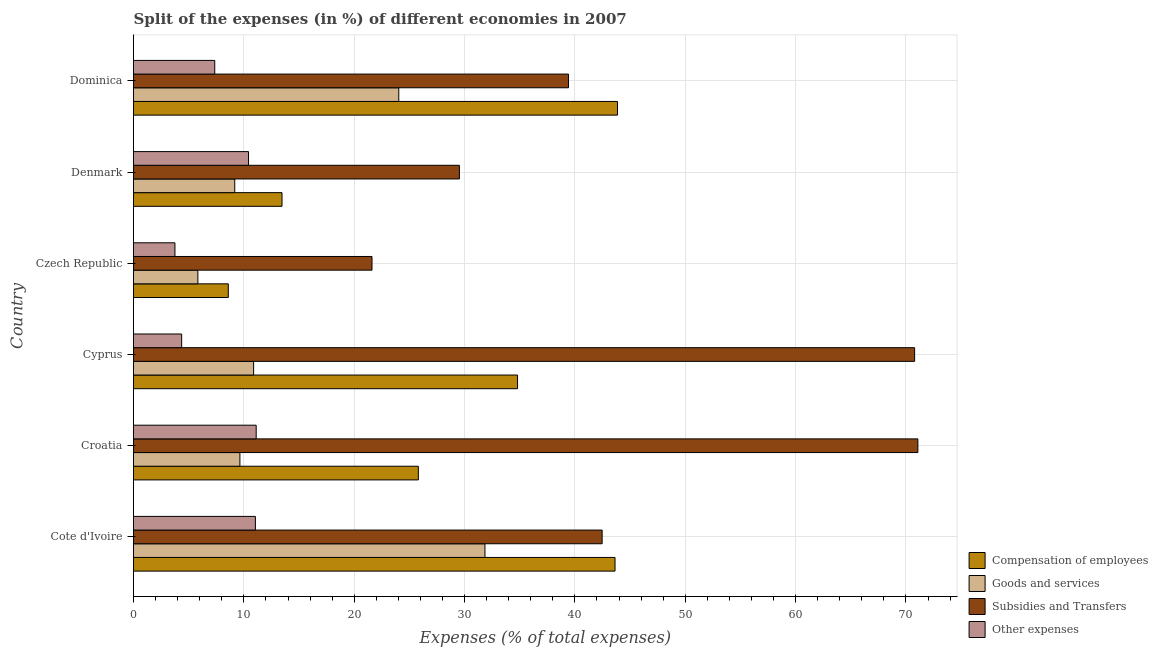How many groups of bars are there?
Give a very brief answer. 6. Are the number of bars per tick equal to the number of legend labels?
Your answer should be very brief. Yes. What is the label of the 2nd group of bars from the top?
Your answer should be compact. Denmark. In how many cases, is the number of bars for a given country not equal to the number of legend labels?
Keep it short and to the point. 0. What is the percentage of amount spent on goods and services in Cote d'Ivoire?
Your response must be concise. 31.85. Across all countries, what is the maximum percentage of amount spent on compensation of employees?
Your answer should be compact. 43.86. Across all countries, what is the minimum percentage of amount spent on subsidies?
Your answer should be compact. 21.61. In which country was the percentage of amount spent on other expenses maximum?
Make the answer very short. Croatia. In which country was the percentage of amount spent on compensation of employees minimum?
Provide a succinct answer. Czech Republic. What is the total percentage of amount spent on subsidies in the graph?
Make the answer very short. 274.9. What is the difference between the percentage of amount spent on compensation of employees in Czech Republic and that in Dominica?
Offer a terse response. -35.27. What is the difference between the percentage of amount spent on other expenses in Croatia and the percentage of amount spent on compensation of employees in Cote d'Ivoire?
Ensure brevity in your answer.  -32.52. What is the average percentage of amount spent on subsidies per country?
Your answer should be very brief. 45.82. What is the difference between the percentage of amount spent on goods and services and percentage of amount spent on other expenses in Cote d'Ivoire?
Provide a succinct answer. 20.8. In how many countries, is the percentage of amount spent on subsidies greater than 54 %?
Keep it short and to the point. 2. What is the ratio of the percentage of amount spent on subsidies in Croatia to that in Dominica?
Offer a terse response. 1.8. What is the difference between the highest and the second highest percentage of amount spent on goods and services?
Offer a very short reply. 7.81. What is the difference between the highest and the lowest percentage of amount spent on subsidies?
Ensure brevity in your answer.  49.47. Is the sum of the percentage of amount spent on compensation of employees in Cote d'Ivoire and Czech Republic greater than the maximum percentage of amount spent on goods and services across all countries?
Offer a very short reply. Yes. What does the 4th bar from the top in Dominica represents?
Offer a terse response. Compensation of employees. What does the 4th bar from the bottom in Czech Republic represents?
Your answer should be very brief. Other expenses. How many countries are there in the graph?
Give a very brief answer. 6. Are the values on the major ticks of X-axis written in scientific E-notation?
Make the answer very short. No. Does the graph contain grids?
Keep it short and to the point. Yes. How many legend labels are there?
Keep it short and to the point. 4. What is the title of the graph?
Give a very brief answer. Split of the expenses (in %) of different economies in 2007. Does "Bird species" appear as one of the legend labels in the graph?
Offer a terse response. No. What is the label or title of the X-axis?
Keep it short and to the point. Expenses (% of total expenses). What is the label or title of the Y-axis?
Offer a terse response. Country. What is the Expenses (% of total expenses) in Compensation of employees in Cote d'Ivoire?
Offer a terse response. 43.64. What is the Expenses (% of total expenses) in Goods and services in Cote d'Ivoire?
Offer a very short reply. 31.85. What is the Expenses (% of total expenses) of Subsidies and Transfers in Cote d'Ivoire?
Your response must be concise. 42.47. What is the Expenses (% of total expenses) in Other expenses in Cote d'Ivoire?
Make the answer very short. 11.04. What is the Expenses (% of total expenses) of Compensation of employees in Croatia?
Offer a very short reply. 25.81. What is the Expenses (% of total expenses) of Goods and services in Croatia?
Keep it short and to the point. 9.64. What is the Expenses (% of total expenses) in Subsidies and Transfers in Croatia?
Make the answer very short. 71.08. What is the Expenses (% of total expenses) in Other expenses in Croatia?
Provide a short and direct response. 11.12. What is the Expenses (% of total expenses) of Compensation of employees in Cyprus?
Give a very brief answer. 34.8. What is the Expenses (% of total expenses) in Goods and services in Cyprus?
Offer a very short reply. 10.89. What is the Expenses (% of total expenses) in Subsidies and Transfers in Cyprus?
Give a very brief answer. 70.79. What is the Expenses (% of total expenses) in Other expenses in Cyprus?
Ensure brevity in your answer.  4.36. What is the Expenses (% of total expenses) of Compensation of employees in Czech Republic?
Offer a terse response. 8.59. What is the Expenses (% of total expenses) in Goods and services in Czech Republic?
Give a very brief answer. 5.83. What is the Expenses (% of total expenses) in Subsidies and Transfers in Czech Republic?
Your response must be concise. 21.61. What is the Expenses (% of total expenses) of Other expenses in Czech Republic?
Provide a short and direct response. 3.75. What is the Expenses (% of total expenses) of Compensation of employees in Denmark?
Your answer should be compact. 13.46. What is the Expenses (% of total expenses) of Goods and services in Denmark?
Ensure brevity in your answer.  9.17. What is the Expenses (% of total expenses) of Subsidies and Transfers in Denmark?
Give a very brief answer. 29.53. What is the Expenses (% of total expenses) in Other expenses in Denmark?
Offer a terse response. 10.42. What is the Expenses (% of total expenses) in Compensation of employees in Dominica?
Provide a short and direct response. 43.86. What is the Expenses (% of total expenses) of Goods and services in Dominica?
Your answer should be very brief. 24.04. What is the Expenses (% of total expenses) of Subsidies and Transfers in Dominica?
Offer a terse response. 39.42. What is the Expenses (% of total expenses) of Other expenses in Dominica?
Make the answer very short. 7.36. Across all countries, what is the maximum Expenses (% of total expenses) in Compensation of employees?
Ensure brevity in your answer.  43.86. Across all countries, what is the maximum Expenses (% of total expenses) in Goods and services?
Offer a very short reply. 31.85. Across all countries, what is the maximum Expenses (% of total expenses) in Subsidies and Transfers?
Provide a succinct answer. 71.08. Across all countries, what is the maximum Expenses (% of total expenses) of Other expenses?
Make the answer very short. 11.12. Across all countries, what is the minimum Expenses (% of total expenses) in Compensation of employees?
Ensure brevity in your answer.  8.59. Across all countries, what is the minimum Expenses (% of total expenses) of Goods and services?
Your answer should be very brief. 5.83. Across all countries, what is the minimum Expenses (% of total expenses) in Subsidies and Transfers?
Keep it short and to the point. 21.61. Across all countries, what is the minimum Expenses (% of total expenses) of Other expenses?
Your answer should be very brief. 3.75. What is the total Expenses (% of total expenses) in Compensation of employees in the graph?
Offer a terse response. 170.16. What is the total Expenses (% of total expenses) in Goods and services in the graph?
Provide a succinct answer. 91.42. What is the total Expenses (% of total expenses) of Subsidies and Transfers in the graph?
Give a very brief answer. 274.9. What is the total Expenses (% of total expenses) of Other expenses in the graph?
Keep it short and to the point. 48.06. What is the difference between the Expenses (% of total expenses) of Compensation of employees in Cote d'Ivoire and that in Croatia?
Give a very brief answer. 17.82. What is the difference between the Expenses (% of total expenses) of Goods and services in Cote d'Ivoire and that in Croatia?
Provide a short and direct response. 22.21. What is the difference between the Expenses (% of total expenses) in Subsidies and Transfers in Cote d'Ivoire and that in Croatia?
Provide a short and direct response. -28.61. What is the difference between the Expenses (% of total expenses) in Other expenses in Cote d'Ivoire and that in Croatia?
Your answer should be compact. -0.07. What is the difference between the Expenses (% of total expenses) in Compensation of employees in Cote d'Ivoire and that in Cyprus?
Make the answer very short. 8.83. What is the difference between the Expenses (% of total expenses) in Goods and services in Cote d'Ivoire and that in Cyprus?
Provide a short and direct response. 20.96. What is the difference between the Expenses (% of total expenses) of Subsidies and Transfers in Cote d'Ivoire and that in Cyprus?
Give a very brief answer. -28.32. What is the difference between the Expenses (% of total expenses) of Other expenses in Cote d'Ivoire and that in Cyprus?
Offer a terse response. 6.68. What is the difference between the Expenses (% of total expenses) in Compensation of employees in Cote d'Ivoire and that in Czech Republic?
Offer a terse response. 35.05. What is the difference between the Expenses (% of total expenses) in Goods and services in Cote d'Ivoire and that in Czech Republic?
Keep it short and to the point. 26.02. What is the difference between the Expenses (% of total expenses) in Subsidies and Transfers in Cote d'Ivoire and that in Czech Republic?
Keep it short and to the point. 20.86. What is the difference between the Expenses (% of total expenses) of Other expenses in Cote d'Ivoire and that in Czech Republic?
Ensure brevity in your answer.  7.29. What is the difference between the Expenses (% of total expenses) of Compensation of employees in Cote d'Ivoire and that in Denmark?
Your response must be concise. 30.18. What is the difference between the Expenses (% of total expenses) in Goods and services in Cote d'Ivoire and that in Denmark?
Make the answer very short. 22.67. What is the difference between the Expenses (% of total expenses) in Subsidies and Transfers in Cote d'Ivoire and that in Denmark?
Provide a short and direct response. 12.93. What is the difference between the Expenses (% of total expenses) of Other expenses in Cote d'Ivoire and that in Denmark?
Your answer should be very brief. 0.62. What is the difference between the Expenses (% of total expenses) of Compensation of employees in Cote d'Ivoire and that in Dominica?
Offer a terse response. -0.22. What is the difference between the Expenses (% of total expenses) in Goods and services in Cote d'Ivoire and that in Dominica?
Provide a succinct answer. 7.81. What is the difference between the Expenses (% of total expenses) of Subsidies and Transfers in Cote d'Ivoire and that in Dominica?
Your response must be concise. 3.05. What is the difference between the Expenses (% of total expenses) of Other expenses in Cote d'Ivoire and that in Dominica?
Keep it short and to the point. 3.68. What is the difference between the Expenses (% of total expenses) of Compensation of employees in Croatia and that in Cyprus?
Give a very brief answer. -8.99. What is the difference between the Expenses (% of total expenses) of Goods and services in Croatia and that in Cyprus?
Your answer should be compact. -1.24. What is the difference between the Expenses (% of total expenses) in Subsidies and Transfers in Croatia and that in Cyprus?
Provide a short and direct response. 0.29. What is the difference between the Expenses (% of total expenses) in Other expenses in Croatia and that in Cyprus?
Ensure brevity in your answer.  6.75. What is the difference between the Expenses (% of total expenses) of Compensation of employees in Croatia and that in Czech Republic?
Provide a short and direct response. 17.22. What is the difference between the Expenses (% of total expenses) of Goods and services in Croatia and that in Czech Republic?
Make the answer very short. 3.81. What is the difference between the Expenses (% of total expenses) of Subsidies and Transfers in Croatia and that in Czech Republic?
Provide a short and direct response. 49.47. What is the difference between the Expenses (% of total expenses) in Other expenses in Croatia and that in Czech Republic?
Keep it short and to the point. 7.36. What is the difference between the Expenses (% of total expenses) of Compensation of employees in Croatia and that in Denmark?
Make the answer very short. 12.35. What is the difference between the Expenses (% of total expenses) of Goods and services in Croatia and that in Denmark?
Make the answer very short. 0.47. What is the difference between the Expenses (% of total expenses) of Subsidies and Transfers in Croatia and that in Denmark?
Your answer should be very brief. 41.55. What is the difference between the Expenses (% of total expenses) of Other expenses in Croatia and that in Denmark?
Provide a short and direct response. 0.7. What is the difference between the Expenses (% of total expenses) in Compensation of employees in Croatia and that in Dominica?
Offer a very short reply. -18.05. What is the difference between the Expenses (% of total expenses) in Goods and services in Croatia and that in Dominica?
Offer a terse response. -14.4. What is the difference between the Expenses (% of total expenses) in Subsidies and Transfers in Croatia and that in Dominica?
Provide a succinct answer. 31.66. What is the difference between the Expenses (% of total expenses) in Other expenses in Croatia and that in Dominica?
Make the answer very short. 3.75. What is the difference between the Expenses (% of total expenses) of Compensation of employees in Cyprus and that in Czech Republic?
Your answer should be compact. 26.21. What is the difference between the Expenses (% of total expenses) of Goods and services in Cyprus and that in Czech Republic?
Make the answer very short. 5.05. What is the difference between the Expenses (% of total expenses) in Subsidies and Transfers in Cyprus and that in Czech Republic?
Offer a terse response. 49.17. What is the difference between the Expenses (% of total expenses) of Other expenses in Cyprus and that in Czech Republic?
Make the answer very short. 0.61. What is the difference between the Expenses (% of total expenses) of Compensation of employees in Cyprus and that in Denmark?
Provide a short and direct response. 21.34. What is the difference between the Expenses (% of total expenses) of Goods and services in Cyprus and that in Denmark?
Offer a terse response. 1.71. What is the difference between the Expenses (% of total expenses) in Subsidies and Transfers in Cyprus and that in Denmark?
Offer a very short reply. 41.25. What is the difference between the Expenses (% of total expenses) in Other expenses in Cyprus and that in Denmark?
Offer a terse response. -6.06. What is the difference between the Expenses (% of total expenses) in Compensation of employees in Cyprus and that in Dominica?
Give a very brief answer. -9.06. What is the difference between the Expenses (% of total expenses) in Goods and services in Cyprus and that in Dominica?
Provide a succinct answer. -13.15. What is the difference between the Expenses (% of total expenses) of Subsidies and Transfers in Cyprus and that in Dominica?
Offer a terse response. 31.37. What is the difference between the Expenses (% of total expenses) in Other expenses in Cyprus and that in Dominica?
Ensure brevity in your answer.  -3. What is the difference between the Expenses (% of total expenses) of Compensation of employees in Czech Republic and that in Denmark?
Your response must be concise. -4.87. What is the difference between the Expenses (% of total expenses) of Goods and services in Czech Republic and that in Denmark?
Give a very brief answer. -3.34. What is the difference between the Expenses (% of total expenses) in Subsidies and Transfers in Czech Republic and that in Denmark?
Make the answer very short. -7.92. What is the difference between the Expenses (% of total expenses) in Other expenses in Czech Republic and that in Denmark?
Ensure brevity in your answer.  -6.67. What is the difference between the Expenses (% of total expenses) in Compensation of employees in Czech Republic and that in Dominica?
Your response must be concise. -35.27. What is the difference between the Expenses (% of total expenses) in Goods and services in Czech Republic and that in Dominica?
Offer a terse response. -18.21. What is the difference between the Expenses (% of total expenses) of Subsidies and Transfers in Czech Republic and that in Dominica?
Ensure brevity in your answer.  -17.81. What is the difference between the Expenses (% of total expenses) in Other expenses in Czech Republic and that in Dominica?
Your answer should be compact. -3.61. What is the difference between the Expenses (% of total expenses) of Compensation of employees in Denmark and that in Dominica?
Offer a very short reply. -30.4. What is the difference between the Expenses (% of total expenses) in Goods and services in Denmark and that in Dominica?
Give a very brief answer. -14.86. What is the difference between the Expenses (% of total expenses) in Subsidies and Transfers in Denmark and that in Dominica?
Give a very brief answer. -9.88. What is the difference between the Expenses (% of total expenses) in Other expenses in Denmark and that in Dominica?
Ensure brevity in your answer.  3.06. What is the difference between the Expenses (% of total expenses) in Compensation of employees in Cote d'Ivoire and the Expenses (% of total expenses) in Goods and services in Croatia?
Offer a very short reply. 33.99. What is the difference between the Expenses (% of total expenses) of Compensation of employees in Cote d'Ivoire and the Expenses (% of total expenses) of Subsidies and Transfers in Croatia?
Make the answer very short. -27.44. What is the difference between the Expenses (% of total expenses) in Compensation of employees in Cote d'Ivoire and the Expenses (% of total expenses) in Other expenses in Croatia?
Your answer should be compact. 32.52. What is the difference between the Expenses (% of total expenses) of Goods and services in Cote d'Ivoire and the Expenses (% of total expenses) of Subsidies and Transfers in Croatia?
Keep it short and to the point. -39.23. What is the difference between the Expenses (% of total expenses) in Goods and services in Cote d'Ivoire and the Expenses (% of total expenses) in Other expenses in Croatia?
Give a very brief answer. 20.73. What is the difference between the Expenses (% of total expenses) of Subsidies and Transfers in Cote d'Ivoire and the Expenses (% of total expenses) of Other expenses in Croatia?
Provide a short and direct response. 31.35. What is the difference between the Expenses (% of total expenses) in Compensation of employees in Cote d'Ivoire and the Expenses (% of total expenses) in Goods and services in Cyprus?
Provide a short and direct response. 32.75. What is the difference between the Expenses (% of total expenses) in Compensation of employees in Cote d'Ivoire and the Expenses (% of total expenses) in Subsidies and Transfers in Cyprus?
Give a very brief answer. -27.15. What is the difference between the Expenses (% of total expenses) of Compensation of employees in Cote d'Ivoire and the Expenses (% of total expenses) of Other expenses in Cyprus?
Keep it short and to the point. 39.27. What is the difference between the Expenses (% of total expenses) in Goods and services in Cote d'Ivoire and the Expenses (% of total expenses) in Subsidies and Transfers in Cyprus?
Ensure brevity in your answer.  -38.94. What is the difference between the Expenses (% of total expenses) in Goods and services in Cote d'Ivoire and the Expenses (% of total expenses) in Other expenses in Cyprus?
Keep it short and to the point. 27.48. What is the difference between the Expenses (% of total expenses) of Subsidies and Transfers in Cote d'Ivoire and the Expenses (% of total expenses) of Other expenses in Cyprus?
Offer a very short reply. 38.1. What is the difference between the Expenses (% of total expenses) of Compensation of employees in Cote d'Ivoire and the Expenses (% of total expenses) of Goods and services in Czech Republic?
Offer a very short reply. 37.8. What is the difference between the Expenses (% of total expenses) in Compensation of employees in Cote d'Ivoire and the Expenses (% of total expenses) in Subsidies and Transfers in Czech Republic?
Provide a short and direct response. 22.02. What is the difference between the Expenses (% of total expenses) in Compensation of employees in Cote d'Ivoire and the Expenses (% of total expenses) in Other expenses in Czech Republic?
Your answer should be compact. 39.88. What is the difference between the Expenses (% of total expenses) of Goods and services in Cote d'Ivoire and the Expenses (% of total expenses) of Subsidies and Transfers in Czech Republic?
Keep it short and to the point. 10.24. What is the difference between the Expenses (% of total expenses) of Goods and services in Cote d'Ivoire and the Expenses (% of total expenses) of Other expenses in Czech Republic?
Your answer should be compact. 28.09. What is the difference between the Expenses (% of total expenses) of Subsidies and Transfers in Cote d'Ivoire and the Expenses (% of total expenses) of Other expenses in Czech Republic?
Your answer should be very brief. 38.71. What is the difference between the Expenses (% of total expenses) in Compensation of employees in Cote d'Ivoire and the Expenses (% of total expenses) in Goods and services in Denmark?
Give a very brief answer. 34.46. What is the difference between the Expenses (% of total expenses) of Compensation of employees in Cote d'Ivoire and the Expenses (% of total expenses) of Subsidies and Transfers in Denmark?
Keep it short and to the point. 14.1. What is the difference between the Expenses (% of total expenses) in Compensation of employees in Cote d'Ivoire and the Expenses (% of total expenses) in Other expenses in Denmark?
Your answer should be very brief. 33.21. What is the difference between the Expenses (% of total expenses) in Goods and services in Cote d'Ivoire and the Expenses (% of total expenses) in Subsidies and Transfers in Denmark?
Make the answer very short. 2.31. What is the difference between the Expenses (% of total expenses) of Goods and services in Cote d'Ivoire and the Expenses (% of total expenses) of Other expenses in Denmark?
Keep it short and to the point. 21.43. What is the difference between the Expenses (% of total expenses) of Subsidies and Transfers in Cote d'Ivoire and the Expenses (% of total expenses) of Other expenses in Denmark?
Give a very brief answer. 32.05. What is the difference between the Expenses (% of total expenses) of Compensation of employees in Cote d'Ivoire and the Expenses (% of total expenses) of Goods and services in Dominica?
Your response must be concise. 19.6. What is the difference between the Expenses (% of total expenses) of Compensation of employees in Cote d'Ivoire and the Expenses (% of total expenses) of Subsidies and Transfers in Dominica?
Give a very brief answer. 4.22. What is the difference between the Expenses (% of total expenses) in Compensation of employees in Cote d'Ivoire and the Expenses (% of total expenses) in Other expenses in Dominica?
Give a very brief answer. 36.27. What is the difference between the Expenses (% of total expenses) of Goods and services in Cote d'Ivoire and the Expenses (% of total expenses) of Subsidies and Transfers in Dominica?
Ensure brevity in your answer.  -7.57. What is the difference between the Expenses (% of total expenses) in Goods and services in Cote d'Ivoire and the Expenses (% of total expenses) in Other expenses in Dominica?
Keep it short and to the point. 24.48. What is the difference between the Expenses (% of total expenses) of Subsidies and Transfers in Cote d'Ivoire and the Expenses (% of total expenses) of Other expenses in Dominica?
Your answer should be very brief. 35.11. What is the difference between the Expenses (% of total expenses) of Compensation of employees in Croatia and the Expenses (% of total expenses) of Goods and services in Cyprus?
Your response must be concise. 14.93. What is the difference between the Expenses (% of total expenses) of Compensation of employees in Croatia and the Expenses (% of total expenses) of Subsidies and Transfers in Cyprus?
Provide a succinct answer. -44.97. What is the difference between the Expenses (% of total expenses) of Compensation of employees in Croatia and the Expenses (% of total expenses) of Other expenses in Cyprus?
Provide a short and direct response. 21.45. What is the difference between the Expenses (% of total expenses) of Goods and services in Croatia and the Expenses (% of total expenses) of Subsidies and Transfers in Cyprus?
Provide a succinct answer. -61.14. What is the difference between the Expenses (% of total expenses) of Goods and services in Croatia and the Expenses (% of total expenses) of Other expenses in Cyprus?
Make the answer very short. 5.28. What is the difference between the Expenses (% of total expenses) of Subsidies and Transfers in Croatia and the Expenses (% of total expenses) of Other expenses in Cyprus?
Provide a short and direct response. 66.72. What is the difference between the Expenses (% of total expenses) in Compensation of employees in Croatia and the Expenses (% of total expenses) in Goods and services in Czech Republic?
Offer a very short reply. 19.98. What is the difference between the Expenses (% of total expenses) of Compensation of employees in Croatia and the Expenses (% of total expenses) of Subsidies and Transfers in Czech Republic?
Your answer should be very brief. 4.2. What is the difference between the Expenses (% of total expenses) in Compensation of employees in Croatia and the Expenses (% of total expenses) in Other expenses in Czech Republic?
Your response must be concise. 22.06. What is the difference between the Expenses (% of total expenses) of Goods and services in Croatia and the Expenses (% of total expenses) of Subsidies and Transfers in Czech Republic?
Give a very brief answer. -11.97. What is the difference between the Expenses (% of total expenses) in Goods and services in Croatia and the Expenses (% of total expenses) in Other expenses in Czech Republic?
Ensure brevity in your answer.  5.89. What is the difference between the Expenses (% of total expenses) in Subsidies and Transfers in Croatia and the Expenses (% of total expenses) in Other expenses in Czech Republic?
Your answer should be compact. 67.33. What is the difference between the Expenses (% of total expenses) of Compensation of employees in Croatia and the Expenses (% of total expenses) of Goods and services in Denmark?
Provide a short and direct response. 16.64. What is the difference between the Expenses (% of total expenses) of Compensation of employees in Croatia and the Expenses (% of total expenses) of Subsidies and Transfers in Denmark?
Give a very brief answer. -3.72. What is the difference between the Expenses (% of total expenses) of Compensation of employees in Croatia and the Expenses (% of total expenses) of Other expenses in Denmark?
Provide a short and direct response. 15.39. What is the difference between the Expenses (% of total expenses) of Goods and services in Croatia and the Expenses (% of total expenses) of Subsidies and Transfers in Denmark?
Keep it short and to the point. -19.89. What is the difference between the Expenses (% of total expenses) of Goods and services in Croatia and the Expenses (% of total expenses) of Other expenses in Denmark?
Provide a succinct answer. -0.78. What is the difference between the Expenses (% of total expenses) in Subsidies and Transfers in Croatia and the Expenses (% of total expenses) in Other expenses in Denmark?
Your response must be concise. 60.66. What is the difference between the Expenses (% of total expenses) of Compensation of employees in Croatia and the Expenses (% of total expenses) of Goods and services in Dominica?
Provide a succinct answer. 1.77. What is the difference between the Expenses (% of total expenses) of Compensation of employees in Croatia and the Expenses (% of total expenses) of Subsidies and Transfers in Dominica?
Make the answer very short. -13.61. What is the difference between the Expenses (% of total expenses) of Compensation of employees in Croatia and the Expenses (% of total expenses) of Other expenses in Dominica?
Ensure brevity in your answer.  18.45. What is the difference between the Expenses (% of total expenses) of Goods and services in Croatia and the Expenses (% of total expenses) of Subsidies and Transfers in Dominica?
Your answer should be compact. -29.78. What is the difference between the Expenses (% of total expenses) of Goods and services in Croatia and the Expenses (% of total expenses) of Other expenses in Dominica?
Offer a terse response. 2.28. What is the difference between the Expenses (% of total expenses) of Subsidies and Transfers in Croatia and the Expenses (% of total expenses) of Other expenses in Dominica?
Make the answer very short. 63.72. What is the difference between the Expenses (% of total expenses) of Compensation of employees in Cyprus and the Expenses (% of total expenses) of Goods and services in Czech Republic?
Keep it short and to the point. 28.97. What is the difference between the Expenses (% of total expenses) of Compensation of employees in Cyprus and the Expenses (% of total expenses) of Subsidies and Transfers in Czech Republic?
Ensure brevity in your answer.  13.19. What is the difference between the Expenses (% of total expenses) in Compensation of employees in Cyprus and the Expenses (% of total expenses) in Other expenses in Czech Republic?
Give a very brief answer. 31.05. What is the difference between the Expenses (% of total expenses) in Goods and services in Cyprus and the Expenses (% of total expenses) in Subsidies and Transfers in Czech Republic?
Ensure brevity in your answer.  -10.73. What is the difference between the Expenses (% of total expenses) of Goods and services in Cyprus and the Expenses (% of total expenses) of Other expenses in Czech Republic?
Your answer should be very brief. 7.13. What is the difference between the Expenses (% of total expenses) of Subsidies and Transfers in Cyprus and the Expenses (% of total expenses) of Other expenses in Czech Republic?
Give a very brief answer. 67.03. What is the difference between the Expenses (% of total expenses) in Compensation of employees in Cyprus and the Expenses (% of total expenses) in Goods and services in Denmark?
Offer a terse response. 25.63. What is the difference between the Expenses (% of total expenses) of Compensation of employees in Cyprus and the Expenses (% of total expenses) of Subsidies and Transfers in Denmark?
Your response must be concise. 5.27. What is the difference between the Expenses (% of total expenses) of Compensation of employees in Cyprus and the Expenses (% of total expenses) of Other expenses in Denmark?
Make the answer very short. 24.38. What is the difference between the Expenses (% of total expenses) of Goods and services in Cyprus and the Expenses (% of total expenses) of Subsidies and Transfers in Denmark?
Your answer should be compact. -18.65. What is the difference between the Expenses (% of total expenses) of Goods and services in Cyprus and the Expenses (% of total expenses) of Other expenses in Denmark?
Offer a very short reply. 0.46. What is the difference between the Expenses (% of total expenses) in Subsidies and Transfers in Cyprus and the Expenses (% of total expenses) in Other expenses in Denmark?
Provide a short and direct response. 60.36. What is the difference between the Expenses (% of total expenses) in Compensation of employees in Cyprus and the Expenses (% of total expenses) in Goods and services in Dominica?
Offer a terse response. 10.76. What is the difference between the Expenses (% of total expenses) of Compensation of employees in Cyprus and the Expenses (% of total expenses) of Subsidies and Transfers in Dominica?
Provide a short and direct response. -4.62. What is the difference between the Expenses (% of total expenses) of Compensation of employees in Cyprus and the Expenses (% of total expenses) of Other expenses in Dominica?
Offer a very short reply. 27.44. What is the difference between the Expenses (% of total expenses) in Goods and services in Cyprus and the Expenses (% of total expenses) in Subsidies and Transfers in Dominica?
Provide a short and direct response. -28.53. What is the difference between the Expenses (% of total expenses) of Goods and services in Cyprus and the Expenses (% of total expenses) of Other expenses in Dominica?
Offer a terse response. 3.52. What is the difference between the Expenses (% of total expenses) in Subsidies and Transfers in Cyprus and the Expenses (% of total expenses) in Other expenses in Dominica?
Keep it short and to the point. 63.42. What is the difference between the Expenses (% of total expenses) in Compensation of employees in Czech Republic and the Expenses (% of total expenses) in Goods and services in Denmark?
Keep it short and to the point. -0.58. What is the difference between the Expenses (% of total expenses) of Compensation of employees in Czech Republic and the Expenses (% of total expenses) of Subsidies and Transfers in Denmark?
Your answer should be compact. -20.94. What is the difference between the Expenses (% of total expenses) of Compensation of employees in Czech Republic and the Expenses (% of total expenses) of Other expenses in Denmark?
Offer a very short reply. -1.83. What is the difference between the Expenses (% of total expenses) in Goods and services in Czech Republic and the Expenses (% of total expenses) in Subsidies and Transfers in Denmark?
Provide a short and direct response. -23.7. What is the difference between the Expenses (% of total expenses) in Goods and services in Czech Republic and the Expenses (% of total expenses) in Other expenses in Denmark?
Ensure brevity in your answer.  -4.59. What is the difference between the Expenses (% of total expenses) in Subsidies and Transfers in Czech Republic and the Expenses (% of total expenses) in Other expenses in Denmark?
Your answer should be compact. 11.19. What is the difference between the Expenses (% of total expenses) of Compensation of employees in Czech Republic and the Expenses (% of total expenses) of Goods and services in Dominica?
Offer a terse response. -15.45. What is the difference between the Expenses (% of total expenses) of Compensation of employees in Czech Republic and the Expenses (% of total expenses) of Subsidies and Transfers in Dominica?
Offer a terse response. -30.83. What is the difference between the Expenses (% of total expenses) in Compensation of employees in Czech Republic and the Expenses (% of total expenses) in Other expenses in Dominica?
Provide a short and direct response. 1.23. What is the difference between the Expenses (% of total expenses) in Goods and services in Czech Republic and the Expenses (% of total expenses) in Subsidies and Transfers in Dominica?
Make the answer very short. -33.59. What is the difference between the Expenses (% of total expenses) of Goods and services in Czech Republic and the Expenses (% of total expenses) of Other expenses in Dominica?
Offer a terse response. -1.53. What is the difference between the Expenses (% of total expenses) in Subsidies and Transfers in Czech Republic and the Expenses (% of total expenses) in Other expenses in Dominica?
Provide a succinct answer. 14.25. What is the difference between the Expenses (% of total expenses) of Compensation of employees in Denmark and the Expenses (% of total expenses) of Goods and services in Dominica?
Make the answer very short. -10.58. What is the difference between the Expenses (% of total expenses) in Compensation of employees in Denmark and the Expenses (% of total expenses) in Subsidies and Transfers in Dominica?
Ensure brevity in your answer.  -25.96. What is the difference between the Expenses (% of total expenses) of Compensation of employees in Denmark and the Expenses (% of total expenses) of Other expenses in Dominica?
Give a very brief answer. 6.09. What is the difference between the Expenses (% of total expenses) of Goods and services in Denmark and the Expenses (% of total expenses) of Subsidies and Transfers in Dominica?
Your response must be concise. -30.24. What is the difference between the Expenses (% of total expenses) of Goods and services in Denmark and the Expenses (% of total expenses) of Other expenses in Dominica?
Your answer should be very brief. 1.81. What is the difference between the Expenses (% of total expenses) of Subsidies and Transfers in Denmark and the Expenses (% of total expenses) of Other expenses in Dominica?
Ensure brevity in your answer.  22.17. What is the average Expenses (% of total expenses) in Compensation of employees per country?
Make the answer very short. 28.36. What is the average Expenses (% of total expenses) of Goods and services per country?
Provide a succinct answer. 15.24. What is the average Expenses (% of total expenses) of Subsidies and Transfers per country?
Provide a short and direct response. 45.82. What is the average Expenses (% of total expenses) of Other expenses per country?
Provide a short and direct response. 8.01. What is the difference between the Expenses (% of total expenses) of Compensation of employees and Expenses (% of total expenses) of Goods and services in Cote d'Ivoire?
Keep it short and to the point. 11.79. What is the difference between the Expenses (% of total expenses) in Compensation of employees and Expenses (% of total expenses) in Subsidies and Transfers in Cote d'Ivoire?
Your answer should be very brief. 1.17. What is the difference between the Expenses (% of total expenses) in Compensation of employees and Expenses (% of total expenses) in Other expenses in Cote d'Ivoire?
Make the answer very short. 32.59. What is the difference between the Expenses (% of total expenses) of Goods and services and Expenses (% of total expenses) of Subsidies and Transfers in Cote d'Ivoire?
Provide a succinct answer. -10.62. What is the difference between the Expenses (% of total expenses) in Goods and services and Expenses (% of total expenses) in Other expenses in Cote d'Ivoire?
Offer a very short reply. 20.8. What is the difference between the Expenses (% of total expenses) in Subsidies and Transfers and Expenses (% of total expenses) in Other expenses in Cote d'Ivoire?
Provide a short and direct response. 31.42. What is the difference between the Expenses (% of total expenses) of Compensation of employees and Expenses (% of total expenses) of Goods and services in Croatia?
Offer a very short reply. 16.17. What is the difference between the Expenses (% of total expenses) in Compensation of employees and Expenses (% of total expenses) in Subsidies and Transfers in Croatia?
Make the answer very short. -45.27. What is the difference between the Expenses (% of total expenses) of Compensation of employees and Expenses (% of total expenses) of Other expenses in Croatia?
Your answer should be very brief. 14.7. What is the difference between the Expenses (% of total expenses) in Goods and services and Expenses (% of total expenses) in Subsidies and Transfers in Croatia?
Ensure brevity in your answer.  -61.44. What is the difference between the Expenses (% of total expenses) of Goods and services and Expenses (% of total expenses) of Other expenses in Croatia?
Your answer should be very brief. -1.48. What is the difference between the Expenses (% of total expenses) of Subsidies and Transfers and Expenses (% of total expenses) of Other expenses in Croatia?
Provide a short and direct response. 59.96. What is the difference between the Expenses (% of total expenses) of Compensation of employees and Expenses (% of total expenses) of Goods and services in Cyprus?
Provide a succinct answer. 23.92. What is the difference between the Expenses (% of total expenses) in Compensation of employees and Expenses (% of total expenses) in Subsidies and Transfers in Cyprus?
Keep it short and to the point. -35.98. What is the difference between the Expenses (% of total expenses) of Compensation of employees and Expenses (% of total expenses) of Other expenses in Cyprus?
Ensure brevity in your answer.  30.44. What is the difference between the Expenses (% of total expenses) in Goods and services and Expenses (% of total expenses) in Subsidies and Transfers in Cyprus?
Ensure brevity in your answer.  -59.9. What is the difference between the Expenses (% of total expenses) in Goods and services and Expenses (% of total expenses) in Other expenses in Cyprus?
Provide a short and direct response. 6.52. What is the difference between the Expenses (% of total expenses) of Subsidies and Transfers and Expenses (% of total expenses) of Other expenses in Cyprus?
Your answer should be compact. 66.42. What is the difference between the Expenses (% of total expenses) of Compensation of employees and Expenses (% of total expenses) of Goods and services in Czech Republic?
Your response must be concise. 2.76. What is the difference between the Expenses (% of total expenses) in Compensation of employees and Expenses (% of total expenses) in Subsidies and Transfers in Czech Republic?
Provide a succinct answer. -13.02. What is the difference between the Expenses (% of total expenses) of Compensation of employees and Expenses (% of total expenses) of Other expenses in Czech Republic?
Offer a very short reply. 4.84. What is the difference between the Expenses (% of total expenses) of Goods and services and Expenses (% of total expenses) of Subsidies and Transfers in Czech Republic?
Provide a short and direct response. -15.78. What is the difference between the Expenses (% of total expenses) in Goods and services and Expenses (% of total expenses) in Other expenses in Czech Republic?
Provide a succinct answer. 2.08. What is the difference between the Expenses (% of total expenses) of Subsidies and Transfers and Expenses (% of total expenses) of Other expenses in Czech Republic?
Give a very brief answer. 17.86. What is the difference between the Expenses (% of total expenses) of Compensation of employees and Expenses (% of total expenses) of Goods and services in Denmark?
Offer a very short reply. 4.28. What is the difference between the Expenses (% of total expenses) in Compensation of employees and Expenses (% of total expenses) in Subsidies and Transfers in Denmark?
Provide a succinct answer. -16.08. What is the difference between the Expenses (% of total expenses) of Compensation of employees and Expenses (% of total expenses) of Other expenses in Denmark?
Give a very brief answer. 3.04. What is the difference between the Expenses (% of total expenses) in Goods and services and Expenses (% of total expenses) in Subsidies and Transfers in Denmark?
Your answer should be compact. -20.36. What is the difference between the Expenses (% of total expenses) in Goods and services and Expenses (% of total expenses) in Other expenses in Denmark?
Your answer should be very brief. -1.25. What is the difference between the Expenses (% of total expenses) of Subsidies and Transfers and Expenses (% of total expenses) of Other expenses in Denmark?
Provide a succinct answer. 19.11. What is the difference between the Expenses (% of total expenses) of Compensation of employees and Expenses (% of total expenses) of Goods and services in Dominica?
Your response must be concise. 19.82. What is the difference between the Expenses (% of total expenses) of Compensation of employees and Expenses (% of total expenses) of Subsidies and Transfers in Dominica?
Your answer should be very brief. 4.44. What is the difference between the Expenses (% of total expenses) of Compensation of employees and Expenses (% of total expenses) of Other expenses in Dominica?
Offer a terse response. 36.5. What is the difference between the Expenses (% of total expenses) in Goods and services and Expenses (% of total expenses) in Subsidies and Transfers in Dominica?
Offer a terse response. -15.38. What is the difference between the Expenses (% of total expenses) of Goods and services and Expenses (% of total expenses) of Other expenses in Dominica?
Your answer should be compact. 16.68. What is the difference between the Expenses (% of total expenses) in Subsidies and Transfers and Expenses (% of total expenses) in Other expenses in Dominica?
Offer a very short reply. 32.05. What is the ratio of the Expenses (% of total expenses) of Compensation of employees in Cote d'Ivoire to that in Croatia?
Your answer should be very brief. 1.69. What is the ratio of the Expenses (% of total expenses) of Goods and services in Cote d'Ivoire to that in Croatia?
Provide a short and direct response. 3.3. What is the ratio of the Expenses (% of total expenses) of Subsidies and Transfers in Cote d'Ivoire to that in Croatia?
Your answer should be very brief. 0.6. What is the ratio of the Expenses (% of total expenses) of Other expenses in Cote d'Ivoire to that in Croatia?
Your answer should be compact. 0.99. What is the ratio of the Expenses (% of total expenses) of Compensation of employees in Cote d'Ivoire to that in Cyprus?
Provide a short and direct response. 1.25. What is the ratio of the Expenses (% of total expenses) of Goods and services in Cote d'Ivoire to that in Cyprus?
Ensure brevity in your answer.  2.93. What is the ratio of the Expenses (% of total expenses) in Other expenses in Cote d'Ivoire to that in Cyprus?
Offer a very short reply. 2.53. What is the ratio of the Expenses (% of total expenses) in Compensation of employees in Cote d'Ivoire to that in Czech Republic?
Keep it short and to the point. 5.08. What is the ratio of the Expenses (% of total expenses) in Goods and services in Cote d'Ivoire to that in Czech Republic?
Ensure brevity in your answer.  5.46. What is the ratio of the Expenses (% of total expenses) of Subsidies and Transfers in Cote d'Ivoire to that in Czech Republic?
Keep it short and to the point. 1.97. What is the ratio of the Expenses (% of total expenses) in Other expenses in Cote d'Ivoire to that in Czech Republic?
Your answer should be compact. 2.94. What is the ratio of the Expenses (% of total expenses) in Compensation of employees in Cote d'Ivoire to that in Denmark?
Ensure brevity in your answer.  3.24. What is the ratio of the Expenses (% of total expenses) of Goods and services in Cote d'Ivoire to that in Denmark?
Provide a succinct answer. 3.47. What is the ratio of the Expenses (% of total expenses) in Subsidies and Transfers in Cote d'Ivoire to that in Denmark?
Keep it short and to the point. 1.44. What is the ratio of the Expenses (% of total expenses) in Other expenses in Cote d'Ivoire to that in Denmark?
Ensure brevity in your answer.  1.06. What is the ratio of the Expenses (% of total expenses) of Goods and services in Cote d'Ivoire to that in Dominica?
Your answer should be very brief. 1.32. What is the ratio of the Expenses (% of total expenses) of Subsidies and Transfers in Cote d'Ivoire to that in Dominica?
Your answer should be compact. 1.08. What is the ratio of the Expenses (% of total expenses) in Other expenses in Cote d'Ivoire to that in Dominica?
Ensure brevity in your answer.  1.5. What is the ratio of the Expenses (% of total expenses) in Compensation of employees in Croatia to that in Cyprus?
Make the answer very short. 0.74. What is the ratio of the Expenses (% of total expenses) in Goods and services in Croatia to that in Cyprus?
Keep it short and to the point. 0.89. What is the ratio of the Expenses (% of total expenses) of Other expenses in Croatia to that in Cyprus?
Give a very brief answer. 2.55. What is the ratio of the Expenses (% of total expenses) of Compensation of employees in Croatia to that in Czech Republic?
Provide a short and direct response. 3. What is the ratio of the Expenses (% of total expenses) of Goods and services in Croatia to that in Czech Republic?
Offer a terse response. 1.65. What is the ratio of the Expenses (% of total expenses) in Subsidies and Transfers in Croatia to that in Czech Republic?
Keep it short and to the point. 3.29. What is the ratio of the Expenses (% of total expenses) in Other expenses in Croatia to that in Czech Republic?
Provide a short and direct response. 2.96. What is the ratio of the Expenses (% of total expenses) of Compensation of employees in Croatia to that in Denmark?
Provide a short and direct response. 1.92. What is the ratio of the Expenses (% of total expenses) of Goods and services in Croatia to that in Denmark?
Ensure brevity in your answer.  1.05. What is the ratio of the Expenses (% of total expenses) of Subsidies and Transfers in Croatia to that in Denmark?
Offer a terse response. 2.41. What is the ratio of the Expenses (% of total expenses) in Other expenses in Croatia to that in Denmark?
Make the answer very short. 1.07. What is the ratio of the Expenses (% of total expenses) of Compensation of employees in Croatia to that in Dominica?
Offer a very short reply. 0.59. What is the ratio of the Expenses (% of total expenses) of Goods and services in Croatia to that in Dominica?
Your answer should be compact. 0.4. What is the ratio of the Expenses (% of total expenses) of Subsidies and Transfers in Croatia to that in Dominica?
Provide a short and direct response. 1.8. What is the ratio of the Expenses (% of total expenses) of Other expenses in Croatia to that in Dominica?
Ensure brevity in your answer.  1.51. What is the ratio of the Expenses (% of total expenses) in Compensation of employees in Cyprus to that in Czech Republic?
Ensure brevity in your answer.  4.05. What is the ratio of the Expenses (% of total expenses) of Goods and services in Cyprus to that in Czech Republic?
Your response must be concise. 1.87. What is the ratio of the Expenses (% of total expenses) in Subsidies and Transfers in Cyprus to that in Czech Republic?
Give a very brief answer. 3.28. What is the ratio of the Expenses (% of total expenses) of Other expenses in Cyprus to that in Czech Republic?
Keep it short and to the point. 1.16. What is the ratio of the Expenses (% of total expenses) in Compensation of employees in Cyprus to that in Denmark?
Your answer should be compact. 2.59. What is the ratio of the Expenses (% of total expenses) in Goods and services in Cyprus to that in Denmark?
Your response must be concise. 1.19. What is the ratio of the Expenses (% of total expenses) in Subsidies and Transfers in Cyprus to that in Denmark?
Offer a terse response. 2.4. What is the ratio of the Expenses (% of total expenses) of Other expenses in Cyprus to that in Denmark?
Offer a very short reply. 0.42. What is the ratio of the Expenses (% of total expenses) of Compensation of employees in Cyprus to that in Dominica?
Give a very brief answer. 0.79. What is the ratio of the Expenses (% of total expenses) in Goods and services in Cyprus to that in Dominica?
Keep it short and to the point. 0.45. What is the ratio of the Expenses (% of total expenses) of Subsidies and Transfers in Cyprus to that in Dominica?
Your answer should be compact. 1.8. What is the ratio of the Expenses (% of total expenses) in Other expenses in Cyprus to that in Dominica?
Offer a terse response. 0.59. What is the ratio of the Expenses (% of total expenses) of Compensation of employees in Czech Republic to that in Denmark?
Offer a terse response. 0.64. What is the ratio of the Expenses (% of total expenses) of Goods and services in Czech Republic to that in Denmark?
Make the answer very short. 0.64. What is the ratio of the Expenses (% of total expenses) of Subsidies and Transfers in Czech Republic to that in Denmark?
Ensure brevity in your answer.  0.73. What is the ratio of the Expenses (% of total expenses) in Other expenses in Czech Republic to that in Denmark?
Your answer should be very brief. 0.36. What is the ratio of the Expenses (% of total expenses) in Compensation of employees in Czech Republic to that in Dominica?
Your answer should be very brief. 0.2. What is the ratio of the Expenses (% of total expenses) of Goods and services in Czech Republic to that in Dominica?
Keep it short and to the point. 0.24. What is the ratio of the Expenses (% of total expenses) of Subsidies and Transfers in Czech Republic to that in Dominica?
Ensure brevity in your answer.  0.55. What is the ratio of the Expenses (% of total expenses) in Other expenses in Czech Republic to that in Dominica?
Make the answer very short. 0.51. What is the ratio of the Expenses (% of total expenses) in Compensation of employees in Denmark to that in Dominica?
Provide a short and direct response. 0.31. What is the ratio of the Expenses (% of total expenses) of Goods and services in Denmark to that in Dominica?
Ensure brevity in your answer.  0.38. What is the ratio of the Expenses (% of total expenses) of Subsidies and Transfers in Denmark to that in Dominica?
Offer a very short reply. 0.75. What is the ratio of the Expenses (% of total expenses) of Other expenses in Denmark to that in Dominica?
Your answer should be very brief. 1.42. What is the difference between the highest and the second highest Expenses (% of total expenses) of Compensation of employees?
Give a very brief answer. 0.22. What is the difference between the highest and the second highest Expenses (% of total expenses) of Goods and services?
Provide a succinct answer. 7.81. What is the difference between the highest and the second highest Expenses (% of total expenses) in Subsidies and Transfers?
Give a very brief answer. 0.29. What is the difference between the highest and the second highest Expenses (% of total expenses) in Other expenses?
Keep it short and to the point. 0.07. What is the difference between the highest and the lowest Expenses (% of total expenses) in Compensation of employees?
Provide a short and direct response. 35.27. What is the difference between the highest and the lowest Expenses (% of total expenses) in Goods and services?
Offer a very short reply. 26.02. What is the difference between the highest and the lowest Expenses (% of total expenses) in Subsidies and Transfers?
Offer a terse response. 49.47. What is the difference between the highest and the lowest Expenses (% of total expenses) of Other expenses?
Provide a short and direct response. 7.36. 